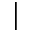<formula> <loc_0><loc_0><loc_500><loc_500>|</formula> 